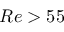Convert formula to latex. <formula><loc_0><loc_0><loc_500><loc_500>R e > 5 5</formula> 